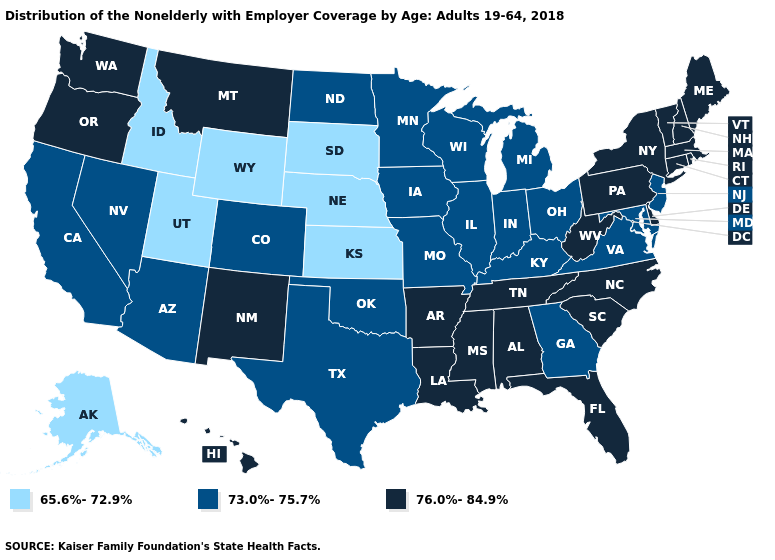What is the highest value in the USA?
Quick response, please. 76.0%-84.9%. Which states hav the highest value in the West?
Keep it brief. Hawaii, Montana, New Mexico, Oregon, Washington. Name the states that have a value in the range 65.6%-72.9%?
Keep it brief. Alaska, Idaho, Kansas, Nebraska, South Dakota, Utah, Wyoming. Name the states that have a value in the range 65.6%-72.9%?
Give a very brief answer. Alaska, Idaho, Kansas, Nebraska, South Dakota, Utah, Wyoming. Does Kentucky have the highest value in the USA?
Write a very short answer. No. What is the value of Minnesota?
Write a very short answer. 73.0%-75.7%. What is the lowest value in states that border Wyoming?
Write a very short answer. 65.6%-72.9%. Which states have the highest value in the USA?
Answer briefly. Alabama, Arkansas, Connecticut, Delaware, Florida, Hawaii, Louisiana, Maine, Massachusetts, Mississippi, Montana, New Hampshire, New Mexico, New York, North Carolina, Oregon, Pennsylvania, Rhode Island, South Carolina, Tennessee, Vermont, Washington, West Virginia. What is the lowest value in the USA?
Quick response, please. 65.6%-72.9%. Name the states that have a value in the range 65.6%-72.9%?
Write a very short answer. Alaska, Idaho, Kansas, Nebraska, South Dakota, Utah, Wyoming. What is the value of New Jersey?
Answer briefly. 73.0%-75.7%. Name the states that have a value in the range 73.0%-75.7%?
Concise answer only. Arizona, California, Colorado, Georgia, Illinois, Indiana, Iowa, Kentucky, Maryland, Michigan, Minnesota, Missouri, Nevada, New Jersey, North Dakota, Ohio, Oklahoma, Texas, Virginia, Wisconsin. Does Nebraska have the lowest value in the USA?
Answer briefly. Yes. Name the states that have a value in the range 73.0%-75.7%?
Short answer required. Arizona, California, Colorado, Georgia, Illinois, Indiana, Iowa, Kentucky, Maryland, Michigan, Minnesota, Missouri, Nevada, New Jersey, North Dakota, Ohio, Oklahoma, Texas, Virginia, Wisconsin. Which states have the lowest value in the USA?
Answer briefly. Alaska, Idaho, Kansas, Nebraska, South Dakota, Utah, Wyoming. 